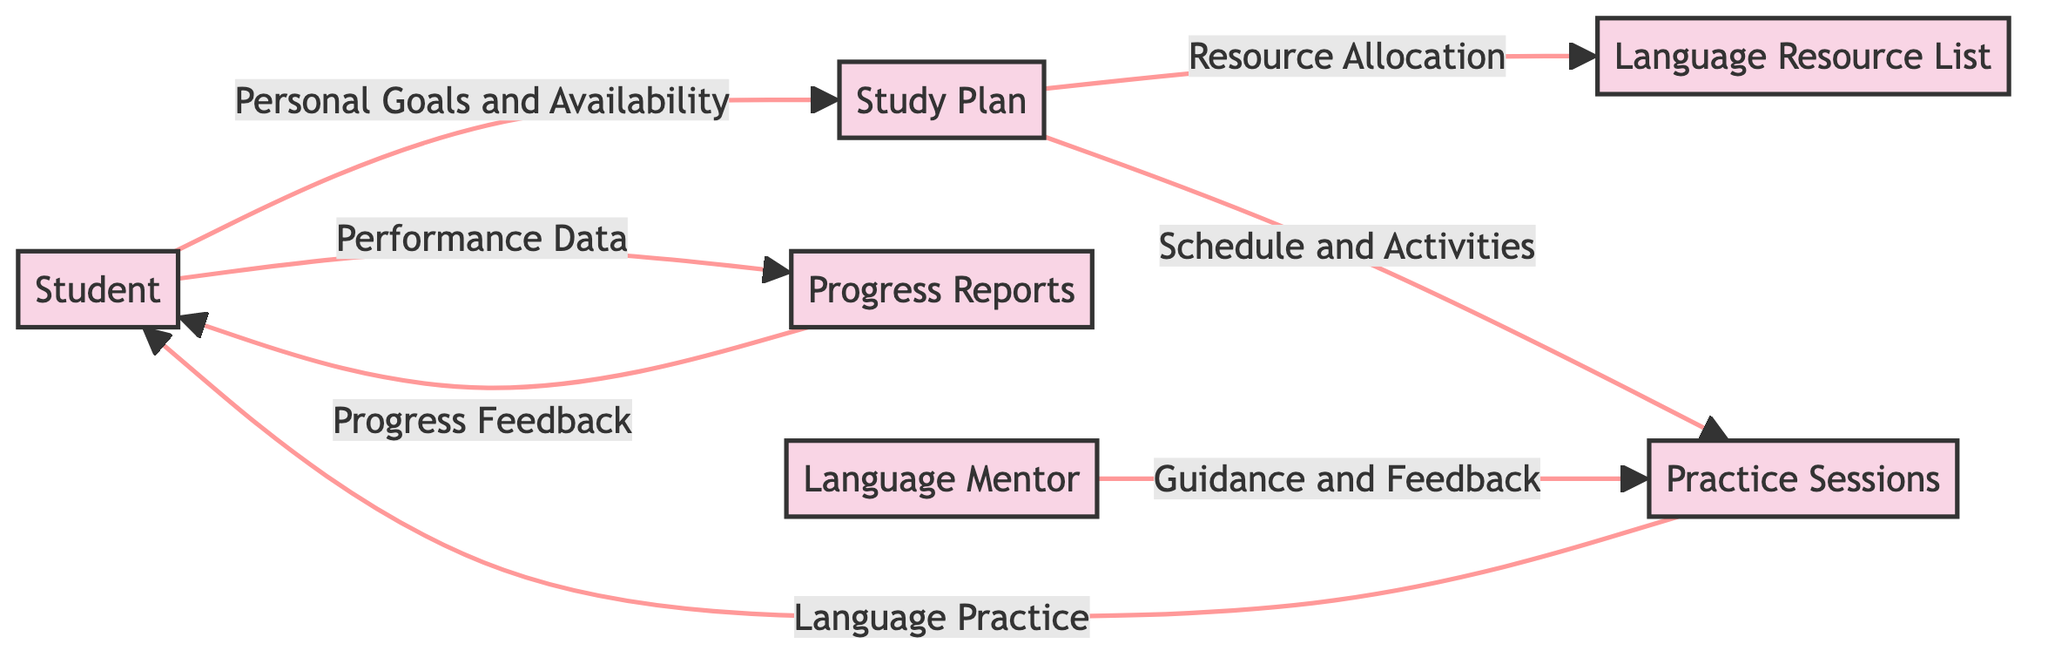What is the source of the data flowing into the Study Plan? The source of the data flowing into the Study Plan is the Student, who provides Personal Goals and Availability.
Answer: Student How many entities are represented in the diagram? There are six entities represented in the diagram: Student, Study Plan, Language Resource List, Practice Sessions, Progress Reports, and Language Mentor.
Answer: 6 What data does the Study Plan send to the Language Resource List? The Study Plan sends Resource Allocation to the Language Resource List.
Answer: Resource Allocation Who provides Guidance and Feedback to the Practice Sessions? The Guidance and Feedback to the Practice Sessions is provided by the Language Mentor.
Answer: Language Mentor What type of data does the Student provide to the Progress Reports? The Student provides Performance Data to the Progress Reports.
Answer: Performance Data What is the final destination of the Progress Feedback in the diagram? The final destination of the Progress Feedback is the Student.
Answer: Student How many data flows are depicted in this diagram? There are seven data flows depicted in the diagram, connecting the various entities with specific data types.
Answer: 7 What is the relationship between the Study Plan and Practice Sessions? The Study Plan sends Schedule and Activities to the Practice Sessions, establishing a structural link between these two entities.
Answer: Schedule and Activities What does the Practice Sessions send back to the Student? The Practice Sessions send Language Practice back to the Student.
Answer: Language Practice 